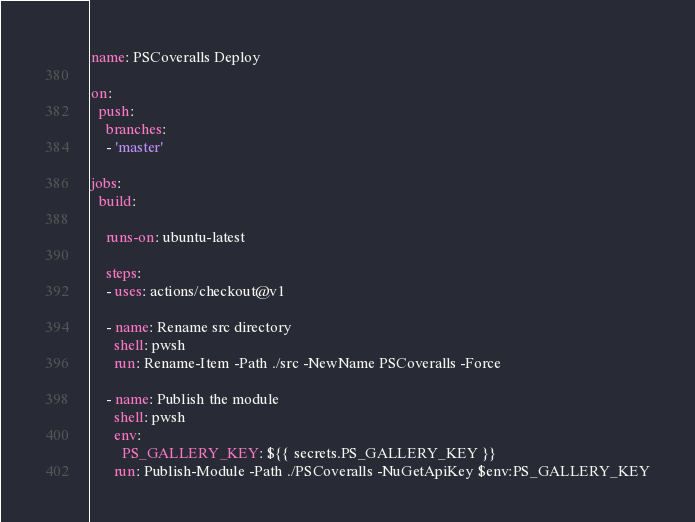<code> <loc_0><loc_0><loc_500><loc_500><_YAML_>name: PSCoveralls Deploy

on:
  push:
    branches:
    - 'master'

jobs:
  build:

    runs-on: ubuntu-latest

    steps:
    - uses: actions/checkout@v1

    - name: Rename src directory
      shell: pwsh
      run: Rename-Item -Path ./src -NewName PSCoveralls -Force

    - name: Publish the module
      shell: pwsh
      env:
        PS_GALLERY_KEY: ${{ secrets.PS_GALLERY_KEY }}
      run: Publish-Module -Path ./PSCoveralls -NuGetApiKey $env:PS_GALLERY_KEY</code> 